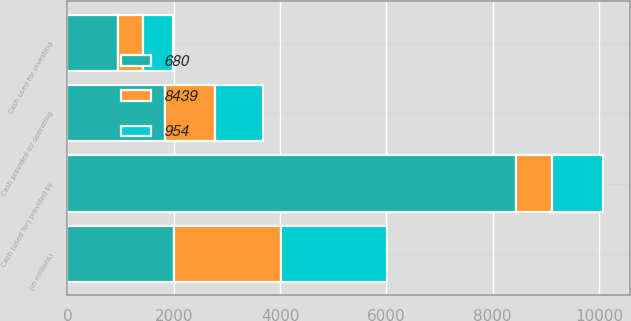Convert chart. <chart><loc_0><loc_0><loc_500><loc_500><stacked_bar_chart><ecel><fcel>(in millions)<fcel>Cash provided by operating<fcel>Cash used for investing<fcel>Cash (used for) provided by<nl><fcel>8439<fcel>2007<fcel>934<fcel>474<fcel>680<nl><fcel>680<fcel>2006<fcel>1845<fcel>954<fcel>8439<nl><fcel>954<fcel>2005<fcel>903<fcel>551<fcel>954<nl></chart> 